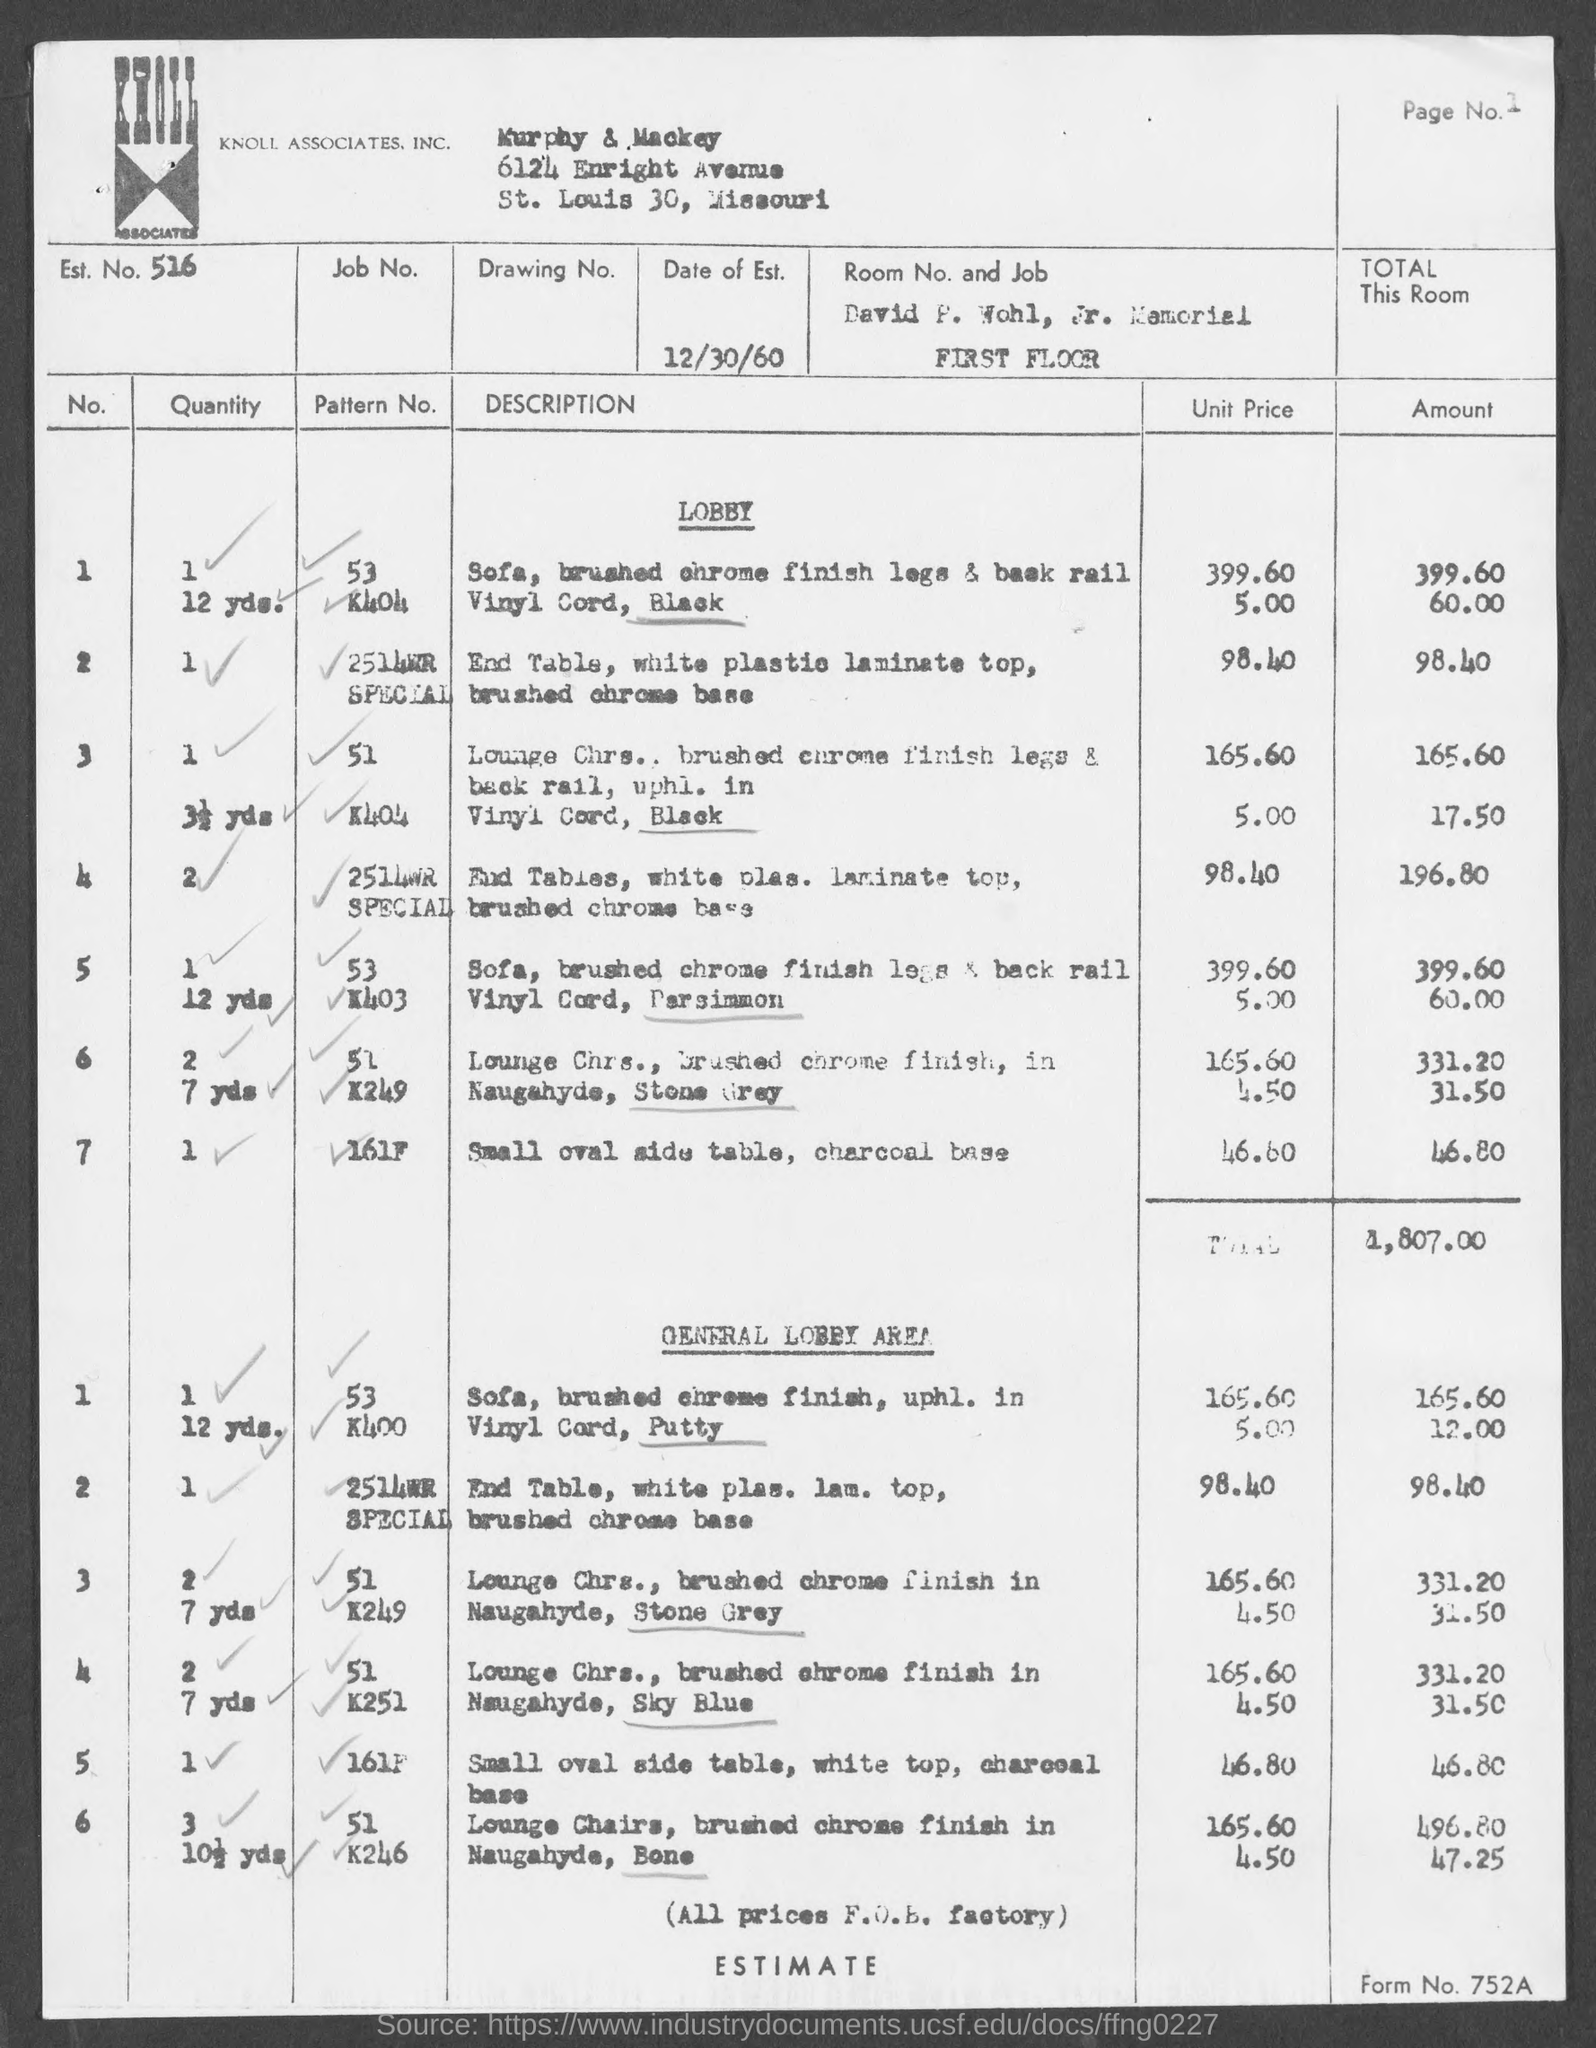Highlight a few significant elements in this photo. What is the estimated number? 516.. I am searching for the page number located in the top-right corner of the page, starting from 1. What is the form number? Murphy & Mackey is currently located in the state of Missouri. 